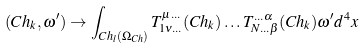<formula> <loc_0><loc_0><loc_500><loc_500>( C h _ { k } , \omega ^ { \prime } ) \to \int _ { C h _ { l } ( \Omega _ { C h } ) } T ^ { \mu \dots } _ { 1 \nu \dots } ( C h _ { k } ) \dots T ^ { \dots \alpha } _ { N \dots \beta } ( C h _ { k } ) \omega ^ { \prime } d ^ { 4 } x</formula> 